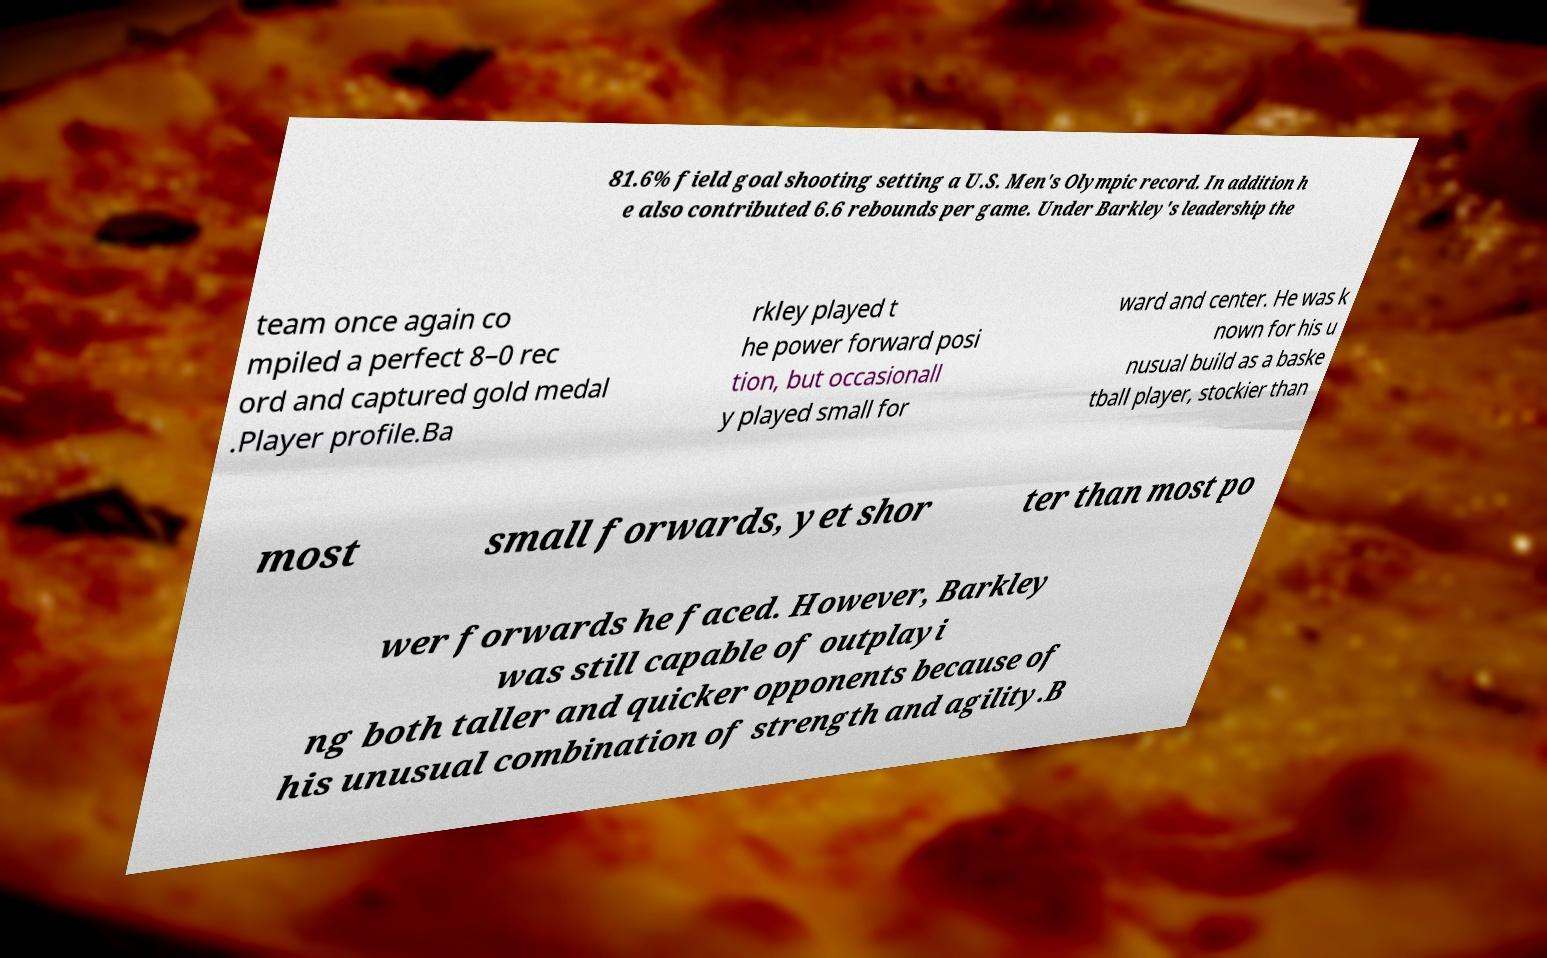There's text embedded in this image that I need extracted. Can you transcribe it verbatim? 81.6% field goal shooting setting a U.S. Men's Olympic record. In addition h e also contributed 6.6 rebounds per game. Under Barkley's leadership the team once again co mpiled a perfect 8–0 rec ord and captured gold medal .Player profile.Ba rkley played t he power forward posi tion, but occasionall y played small for ward and center. He was k nown for his u nusual build as a baske tball player, stockier than most small forwards, yet shor ter than most po wer forwards he faced. However, Barkley was still capable of outplayi ng both taller and quicker opponents because of his unusual combination of strength and agility.B 